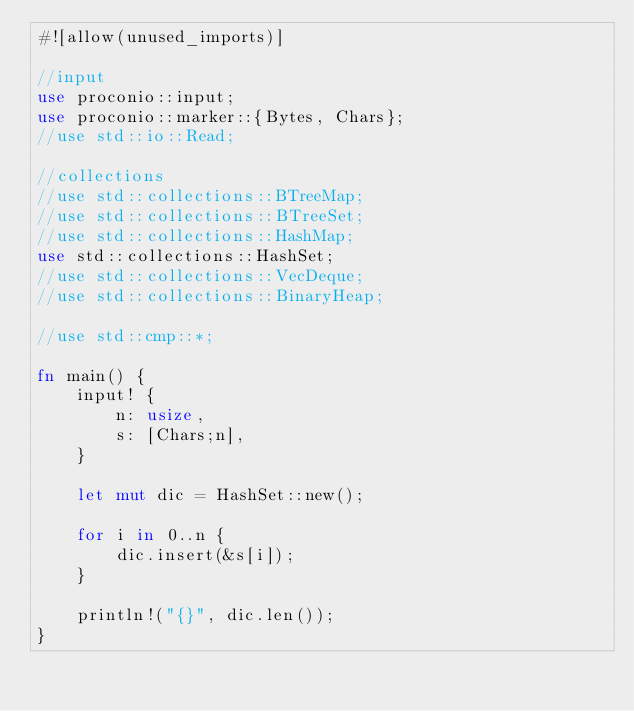Convert code to text. <code><loc_0><loc_0><loc_500><loc_500><_Rust_>#![allow(unused_imports)]

//input
use proconio::input;
use proconio::marker::{Bytes, Chars};
//use std::io::Read;

//collections
//use std::collections::BTreeMap;
//use std::collections::BTreeSet;
//use std::collections::HashMap;
use std::collections::HashSet;
//use std::collections::VecDeque;
//use std::collections::BinaryHeap;

//use std::cmp::*;

fn main() {
    input! {
        n: usize,
        s: [Chars;n],
    }

    let mut dic = HashSet::new();

    for i in 0..n {
        dic.insert(&s[i]);
    }

    println!("{}", dic.len());
}
</code> 